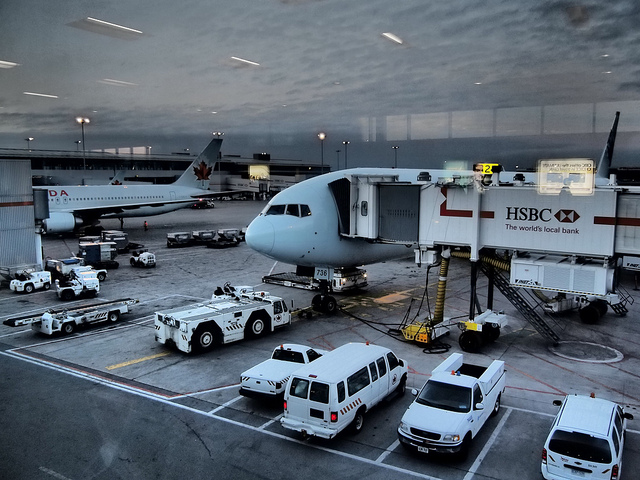Please identify all text content in this image. HSBC bank 2 